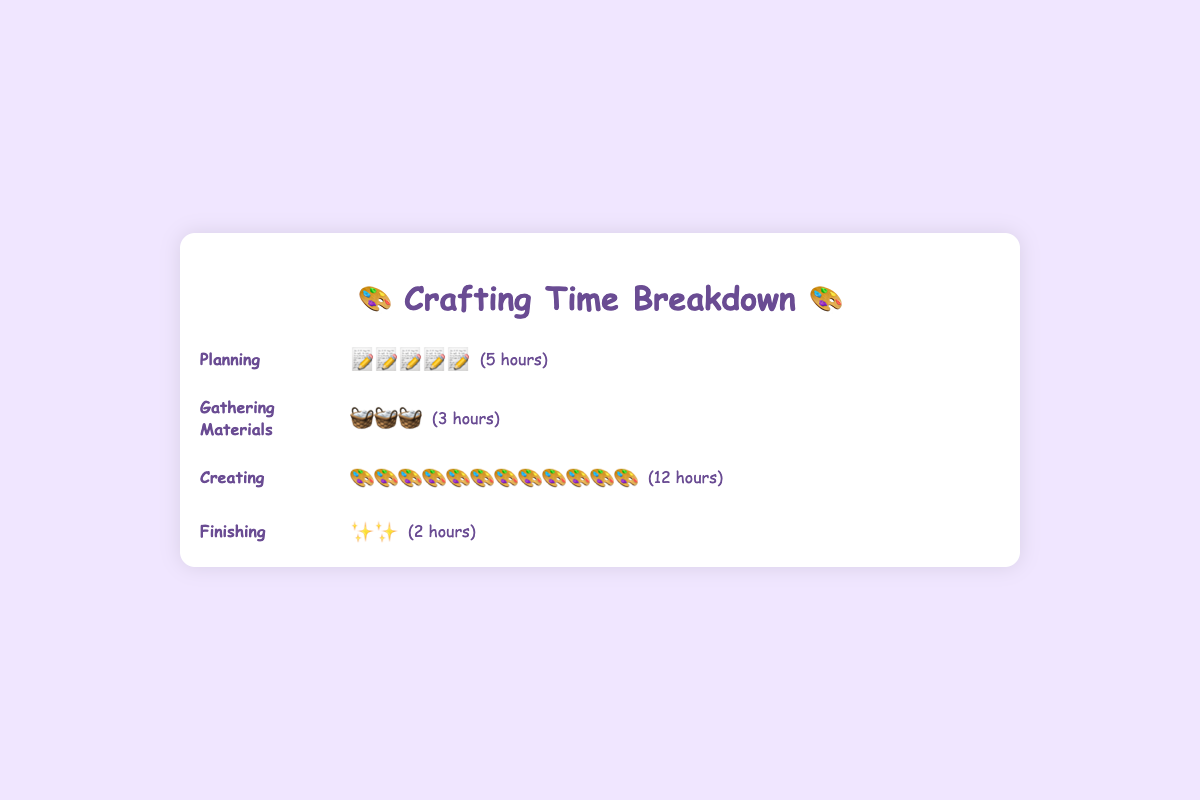What is the total time spent on Planning? The figure shows the Planning stage with 5 icons, each representing 1 hour. Therefore, the total time spent on Planning is 5 hours.
Answer: 5 hours Which stage has the longest duration? The Creating stage has the longest duration, represented by the most icons (12 icons, each representing 1 hour).
Answer: Creating What is the total time spent on all stages combined? The total time is the sum of hours spent on each stage: Planning (5) + Gathering Materials (3) + Creating (12) + Finishing (2) = 22 hours.
Answer: 22 hours How much more time is spent on Creating compared to Finishing? Time on Creating is 12 hours, and time on Finishing is 2 hours. The difference is 12 - 2 = 10 hours.
Answer: 10 hours Which stage takes less time, Gathering Materials or Finishing? The figure shows 3 hours for Gathering Materials and 2 hours for Finishing. Finishing takes less time.
Answer: Finishing What is the average time spent per stage? Total time spent is 22 hours, and there are 4 stages. The average time is 22 / 4 = 5.5 hours per stage.
Answer: 5.5 hours How many total icons represent the Creating stage? The Creating stage has 12 icons, with each icon representing 1 hour.
Answer: 12 icons Is the time spent on Planning equal to the time spent on Gathering Materials and Finishing combined? Time on Planning is 5 hours, and combined time on Gathering Materials (3) and Finishing (2) is 3 + 2 = 5 hours. They are equal.
Answer: Yes What proportion of the total time is spent on Creating? Time spent on Creating is 12 hours out of the total 22 hours. The proportion is 12 / 22 = 0.545, approximately 54.5%.
Answer: 54.5% Between Planning and Gathering Materials, which stage has fewer hours? Planning has 5 hours, while Gathering Materials has 3 hours. Gathering Materials has fewer hours.
Answer: Gathering Materials 